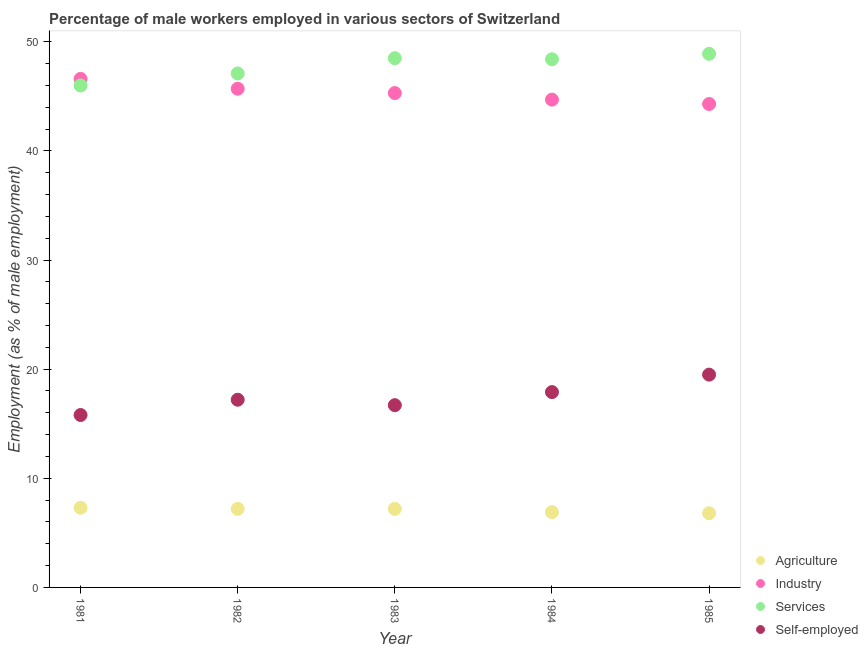How many different coloured dotlines are there?
Offer a terse response. 4. What is the percentage of self employed male workers in 1983?
Keep it short and to the point. 16.7. Across all years, what is the minimum percentage of male workers in agriculture?
Provide a succinct answer. 6.8. In which year was the percentage of self employed male workers maximum?
Offer a very short reply. 1985. What is the total percentage of male workers in industry in the graph?
Your response must be concise. 226.6. What is the difference between the percentage of self employed male workers in 1981 and that in 1983?
Keep it short and to the point. -0.9. What is the difference between the percentage of self employed male workers in 1981 and the percentage of male workers in industry in 1984?
Offer a terse response. -28.9. What is the average percentage of male workers in industry per year?
Make the answer very short. 45.32. In the year 1983, what is the difference between the percentage of self employed male workers and percentage of male workers in services?
Your response must be concise. -31.8. Is the percentage of male workers in agriculture in 1981 less than that in 1984?
Make the answer very short. No. What is the difference between the highest and the second highest percentage of male workers in agriculture?
Provide a succinct answer. 0.1. What is the difference between the highest and the lowest percentage of male workers in industry?
Make the answer very short. 2.3. Is it the case that in every year, the sum of the percentage of male workers in agriculture and percentage of self employed male workers is greater than the sum of percentage of male workers in services and percentage of male workers in industry?
Provide a succinct answer. No. Does the percentage of male workers in industry monotonically increase over the years?
Offer a terse response. No. Is the percentage of male workers in services strictly less than the percentage of male workers in agriculture over the years?
Your response must be concise. No. Are the values on the major ticks of Y-axis written in scientific E-notation?
Make the answer very short. No. Does the graph contain any zero values?
Your response must be concise. No. How many legend labels are there?
Your answer should be very brief. 4. What is the title of the graph?
Keep it short and to the point. Percentage of male workers employed in various sectors of Switzerland. Does "Tertiary schools" appear as one of the legend labels in the graph?
Your answer should be compact. No. What is the label or title of the Y-axis?
Offer a very short reply. Employment (as % of male employment). What is the Employment (as % of male employment) in Agriculture in 1981?
Offer a very short reply. 7.3. What is the Employment (as % of male employment) in Industry in 1981?
Your answer should be very brief. 46.6. What is the Employment (as % of male employment) of Self-employed in 1981?
Give a very brief answer. 15.8. What is the Employment (as % of male employment) of Agriculture in 1982?
Provide a succinct answer. 7.2. What is the Employment (as % of male employment) in Industry in 1982?
Keep it short and to the point. 45.7. What is the Employment (as % of male employment) in Services in 1982?
Make the answer very short. 47.1. What is the Employment (as % of male employment) of Self-employed in 1982?
Provide a succinct answer. 17.2. What is the Employment (as % of male employment) of Agriculture in 1983?
Provide a succinct answer. 7.2. What is the Employment (as % of male employment) of Industry in 1983?
Provide a succinct answer. 45.3. What is the Employment (as % of male employment) in Services in 1983?
Give a very brief answer. 48.5. What is the Employment (as % of male employment) in Self-employed in 1983?
Provide a succinct answer. 16.7. What is the Employment (as % of male employment) of Agriculture in 1984?
Offer a terse response. 6.9. What is the Employment (as % of male employment) of Industry in 1984?
Ensure brevity in your answer.  44.7. What is the Employment (as % of male employment) in Services in 1984?
Keep it short and to the point. 48.4. What is the Employment (as % of male employment) in Self-employed in 1984?
Ensure brevity in your answer.  17.9. What is the Employment (as % of male employment) in Agriculture in 1985?
Your answer should be compact. 6.8. What is the Employment (as % of male employment) of Industry in 1985?
Offer a terse response. 44.3. What is the Employment (as % of male employment) in Services in 1985?
Your answer should be very brief. 48.9. What is the Employment (as % of male employment) in Self-employed in 1985?
Ensure brevity in your answer.  19.5. Across all years, what is the maximum Employment (as % of male employment) of Agriculture?
Provide a short and direct response. 7.3. Across all years, what is the maximum Employment (as % of male employment) in Industry?
Provide a short and direct response. 46.6. Across all years, what is the maximum Employment (as % of male employment) in Services?
Provide a succinct answer. 48.9. Across all years, what is the minimum Employment (as % of male employment) in Agriculture?
Your answer should be compact. 6.8. Across all years, what is the minimum Employment (as % of male employment) of Industry?
Ensure brevity in your answer.  44.3. Across all years, what is the minimum Employment (as % of male employment) in Self-employed?
Provide a succinct answer. 15.8. What is the total Employment (as % of male employment) of Agriculture in the graph?
Your response must be concise. 35.4. What is the total Employment (as % of male employment) of Industry in the graph?
Offer a very short reply. 226.6. What is the total Employment (as % of male employment) in Services in the graph?
Provide a short and direct response. 238.9. What is the total Employment (as % of male employment) in Self-employed in the graph?
Keep it short and to the point. 87.1. What is the difference between the Employment (as % of male employment) in Agriculture in 1981 and that in 1982?
Provide a short and direct response. 0.1. What is the difference between the Employment (as % of male employment) of Services in 1981 and that in 1982?
Offer a terse response. -1.1. What is the difference between the Employment (as % of male employment) in Self-employed in 1981 and that in 1982?
Ensure brevity in your answer.  -1.4. What is the difference between the Employment (as % of male employment) in Agriculture in 1981 and that in 1983?
Your answer should be compact. 0.1. What is the difference between the Employment (as % of male employment) in Agriculture in 1981 and that in 1984?
Your response must be concise. 0.4. What is the difference between the Employment (as % of male employment) of Industry in 1981 and that in 1984?
Give a very brief answer. 1.9. What is the difference between the Employment (as % of male employment) in Agriculture in 1981 and that in 1985?
Make the answer very short. 0.5. What is the difference between the Employment (as % of male employment) in Agriculture in 1982 and that in 1983?
Your answer should be compact. 0. What is the difference between the Employment (as % of male employment) in Services in 1982 and that in 1983?
Your answer should be compact. -1.4. What is the difference between the Employment (as % of male employment) of Agriculture in 1982 and that in 1985?
Your response must be concise. 0.4. What is the difference between the Employment (as % of male employment) of Industry in 1982 and that in 1985?
Give a very brief answer. 1.4. What is the difference between the Employment (as % of male employment) of Self-employed in 1982 and that in 1985?
Offer a terse response. -2.3. What is the difference between the Employment (as % of male employment) of Agriculture in 1983 and that in 1984?
Give a very brief answer. 0.3. What is the difference between the Employment (as % of male employment) of Industry in 1983 and that in 1984?
Your answer should be compact. 0.6. What is the difference between the Employment (as % of male employment) in Self-employed in 1983 and that in 1984?
Your answer should be compact. -1.2. What is the difference between the Employment (as % of male employment) of Agriculture in 1983 and that in 1985?
Your answer should be very brief. 0.4. What is the difference between the Employment (as % of male employment) of Services in 1983 and that in 1985?
Keep it short and to the point. -0.4. What is the difference between the Employment (as % of male employment) in Self-employed in 1983 and that in 1985?
Your response must be concise. -2.8. What is the difference between the Employment (as % of male employment) in Industry in 1984 and that in 1985?
Provide a succinct answer. 0.4. What is the difference between the Employment (as % of male employment) in Agriculture in 1981 and the Employment (as % of male employment) in Industry in 1982?
Give a very brief answer. -38.4. What is the difference between the Employment (as % of male employment) of Agriculture in 1981 and the Employment (as % of male employment) of Services in 1982?
Your answer should be compact. -39.8. What is the difference between the Employment (as % of male employment) of Agriculture in 1981 and the Employment (as % of male employment) of Self-employed in 1982?
Keep it short and to the point. -9.9. What is the difference between the Employment (as % of male employment) in Industry in 1981 and the Employment (as % of male employment) in Services in 1982?
Your response must be concise. -0.5. What is the difference between the Employment (as % of male employment) of Industry in 1981 and the Employment (as % of male employment) of Self-employed in 1982?
Offer a terse response. 29.4. What is the difference between the Employment (as % of male employment) of Services in 1981 and the Employment (as % of male employment) of Self-employed in 1982?
Your answer should be compact. 28.8. What is the difference between the Employment (as % of male employment) in Agriculture in 1981 and the Employment (as % of male employment) in Industry in 1983?
Ensure brevity in your answer.  -38. What is the difference between the Employment (as % of male employment) in Agriculture in 1981 and the Employment (as % of male employment) in Services in 1983?
Provide a succinct answer. -41.2. What is the difference between the Employment (as % of male employment) of Agriculture in 1981 and the Employment (as % of male employment) of Self-employed in 1983?
Offer a very short reply. -9.4. What is the difference between the Employment (as % of male employment) in Industry in 1981 and the Employment (as % of male employment) in Services in 1983?
Your response must be concise. -1.9. What is the difference between the Employment (as % of male employment) of Industry in 1981 and the Employment (as % of male employment) of Self-employed in 1983?
Offer a terse response. 29.9. What is the difference between the Employment (as % of male employment) in Services in 1981 and the Employment (as % of male employment) in Self-employed in 1983?
Provide a short and direct response. 29.3. What is the difference between the Employment (as % of male employment) of Agriculture in 1981 and the Employment (as % of male employment) of Industry in 1984?
Offer a very short reply. -37.4. What is the difference between the Employment (as % of male employment) in Agriculture in 1981 and the Employment (as % of male employment) in Services in 1984?
Your answer should be compact. -41.1. What is the difference between the Employment (as % of male employment) of Agriculture in 1981 and the Employment (as % of male employment) of Self-employed in 1984?
Ensure brevity in your answer.  -10.6. What is the difference between the Employment (as % of male employment) in Industry in 1981 and the Employment (as % of male employment) in Self-employed in 1984?
Provide a short and direct response. 28.7. What is the difference between the Employment (as % of male employment) in Services in 1981 and the Employment (as % of male employment) in Self-employed in 1984?
Your answer should be compact. 28.1. What is the difference between the Employment (as % of male employment) of Agriculture in 1981 and the Employment (as % of male employment) of Industry in 1985?
Ensure brevity in your answer.  -37. What is the difference between the Employment (as % of male employment) of Agriculture in 1981 and the Employment (as % of male employment) of Services in 1985?
Keep it short and to the point. -41.6. What is the difference between the Employment (as % of male employment) of Agriculture in 1981 and the Employment (as % of male employment) of Self-employed in 1985?
Your answer should be very brief. -12.2. What is the difference between the Employment (as % of male employment) in Industry in 1981 and the Employment (as % of male employment) in Services in 1985?
Offer a very short reply. -2.3. What is the difference between the Employment (as % of male employment) in Industry in 1981 and the Employment (as % of male employment) in Self-employed in 1985?
Make the answer very short. 27.1. What is the difference between the Employment (as % of male employment) of Services in 1981 and the Employment (as % of male employment) of Self-employed in 1985?
Offer a terse response. 26.5. What is the difference between the Employment (as % of male employment) of Agriculture in 1982 and the Employment (as % of male employment) of Industry in 1983?
Your answer should be compact. -38.1. What is the difference between the Employment (as % of male employment) of Agriculture in 1982 and the Employment (as % of male employment) of Services in 1983?
Keep it short and to the point. -41.3. What is the difference between the Employment (as % of male employment) of Agriculture in 1982 and the Employment (as % of male employment) of Self-employed in 1983?
Your response must be concise. -9.5. What is the difference between the Employment (as % of male employment) of Services in 1982 and the Employment (as % of male employment) of Self-employed in 1983?
Make the answer very short. 30.4. What is the difference between the Employment (as % of male employment) in Agriculture in 1982 and the Employment (as % of male employment) in Industry in 1984?
Your response must be concise. -37.5. What is the difference between the Employment (as % of male employment) of Agriculture in 1982 and the Employment (as % of male employment) of Services in 1984?
Your answer should be very brief. -41.2. What is the difference between the Employment (as % of male employment) in Industry in 1982 and the Employment (as % of male employment) in Self-employed in 1984?
Your answer should be compact. 27.8. What is the difference between the Employment (as % of male employment) in Services in 1982 and the Employment (as % of male employment) in Self-employed in 1984?
Provide a short and direct response. 29.2. What is the difference between the Employment (as % of male employment) of Agriculture in 1982 and the Employment (as % of male employment) of Industry in 1985?
Provide a succinct answer. -37.1. What is the difference between the Employment (as % of male employment) in Agriculture in 1982 and the Employment (as % of male employment) in Services in 1985?
Provide a succinct answer. -41.7. What is the difference between the Employment (as % of male employment) of Industry in 1982 and the Employment (as % of male employment) of Services in 1985?
Offer a terse response. -3.2. What is the difference between the Employment (as % of male employment) of Industry in 1982 and the Employment (as % of male employment) of Self-employed in 1985?
Give a very brief answer. 26.2. What is the difference between the Employment (as % of male employment) of Services in 1982 and the Employment (as % of male employment) of Self-employed in 1985?
Keep it short and to the point. 27.6. What is the difference between the Employment (as % of male employment) in Agriculture in 1983 and the Employment (as % of male employment) in Industry in 1984?
Offer a terse response. -37.5. What is the difference between the Employment (as % of male employment) in Agriculture in 1983 and the Employment (as % of male employment) in Services in 1984?
Your response must be concise. -41.2. What is the difference between the Employment (as % of male employment) in Industry in 1983 and the Employment (as % of male employment) in Services in 1984?
Offer a terse response. -3.1. What is the difference between the Employment (as % of male employment) in Industry in 1983 and the Employment (as % of male employment) in Self-employed in 1984?
Your answer should be compact. 27.4. What is the difference between the Employment (as % of male employment) in Services in 1983 and the Employment (as % of male employment) in Self-employed in 1984?
Give a very brief answer. 30.6. What is the difference between the Employment (as % of male employment) in Agriculture in 1983 and the Employment (as % of male employment) in Industry in 1985?
Keep it short and to the point. -37.1. What is the difference between the Employment (as % of male employment) of Agriculture in 1983 and the Employment (as % of male employment) of Services in 1985?
Make the answer very short. -41.7. What is the difference between the Employment (as % of male employment) of Agriculture in 1983 and the Employment (as % of male employment) of Self-employed in 1985?
Offer a terse response. -12.3. What is the difference between the Employment (as % of male employment) of Industry in 1983 and the Employment (as % of male employment) of Self-employed in 1985?
Ensure brevity in your answer.  25.8. What is the difference between the Employment (as % of male employment) of Agriculture in 1984 and the Employment (as % of male employment) of Industry in 1985?
Keep it short and to the point. -37.4. What is the difference between the Employment (as % of male employment) of Agriculture in 1984 and the Employment (as % of male employment) of Services in 1985?
Keep it short and to the point. -42. What is the difference between the Employment (as % of male employment) in Agriculture in 1984 and the Employment (as % of male employment) in Self-employed in 1985?
Make the answer very short. -12.6. What is the difference between the Employment (as % of male employment) in Industry in 1984 and the Employment (as % of male employment) in Self-employed in 1985?
Your answer should be compact. 25.2. What is the difference between the Employment (as % of male employment) in Services in 1984 and the Employment (as % of male employment) in Self-employed in 1985?
Ensure brevity in your answer.  28.9. What is the average Employment (as % of male employment) of Agriculture per year?
Ensure brevity in your answer.  7.08. What is the average Employment (as % of male employment) of Industry per year?
Your response must be concise. 45.32. What is the average Employment (as % of male employment) of Services per year?
Ensure brevity in your answer.  47.78. What is the average Employment (as % of male employment) in Self-employed per year?
Provide a succinct answer. 17.42. In the year 1981, what is the difference between the Employment (as % of male employment) in Agriculture and Employment (as % of male employment) in Industry?
Your answer should be very brief. -39.3. In the year 1981, what is the difference between the Employment (as % of male employment) of Agriculture and Employment (as % of male employment) of Services?
Your response must be concise. -38.7. In the year 1981, what is the difference between the Employment (as % of male employment) in Agriculture and Employment (as % of male employment) in Self-employed?
Offer a very short reply. -8.5. In the year 1981, what is the difference between the Employment (as % of male employment) in Industry and Employment (as % of male employment) in Self-employed?
Keep it short and to the point. 30.8. In the year 1981, what is the difference between the Employment (as % of male employment) of Services and Employment (as % of male employment) of Self-employed?
Give a very brief answer. 30.2. In the year 1982, what is the difference between the Employment (as % of male employment) of Agriculture and Employment (as % of male employment) of Industry?
Offer a very short reply. -38.5. In the year 1982, what is the difference between the Employment (as % of male employment) of Agriculture and Employment (as % of male employment) of Services?
Your answer should be very brief. -39.9. In the year 1982, what is the difference between the Employment (as % of male employment) of Industry and Employment (as % of male employment) of Services?
Keep it short and to the point. -1.4. In the year 1982, what is the difference between the Employment (as % of male employment) in Industry and Employment (as % of male employment) in Self-employed?
Provide a short and direct response. 28.5. In the year 1982, what is the difference between the Employment (as % of male employment) of Services and Employment (as % of male employment) of Self-employed?
Provide a succinct answer. 29.9. In the year 1983, what is the difference between the Employment (as % of male employment) of Agriculture and Employment (as % of male employment) of Industry?
Provide a short and direct response. -38.1. In the year 1983, what is the difference between the Employment (as % of male employment) in Agriculture and Employment (as % of male employment) in Services?
Keep it short and to the point. -41.3. In the year 1983, what is the difference between the Employment (as % of male employment) in Agriculture and Employment (as % of male employment) in Self-employed?
Your answer should be very brief. -9.5. In the year 1983, what is the difference between the Employment (as % of male employment) in Industry and Employment (as % of male employment) in Self-employed?
Give a very brief answer. 28.6. In the year 1983, what is the difference between the Employment (as % of male employment) of Services and Employment (as % of male employment) of Self-employed?
Provide a succinct answer. 31.8. In the year 1984, what is the difference between the Employment (as % of male employment) of Agriculture and Employment (as % of male employment) of Industry?
Give a very brief answer. -37.8. In the year 1984, what is the difference between the Employment (as % of male employment) of Agriculture and Employment (as % of male employment) of Services?
Offer a very short reply. -41.5. In the year 1984, what is the difference between the Employment (as % of male employment) of Industry and Employment (as % of male employment) of Services?
Offer a very short reply. -3.7. In the year 1984, what is the difference between the Employment (as % of male employment) in Industry and Employment (as % of male employment) in Self-employed?
Provide a succinct answer. 26.8. In the year 1984, what is the difference between the Employment (as % of male employment) of Services and Employment (as % of male employment) of Self-employed?
Your response must be concise. 30.5. In the year 1985, what is the difference between the Employment (as % of male employment) in Agriculture and Employment (as % of male employment) in Industry?
Your answer should be compact. -37.5. In the year 1985, what is the difference between the Employment (as % of male employment) in Agriculture and Employment (as % of male employment) in Services?
Keep it short and to the point. -42.1. In the year 1985, what is the difference between the Employment (as % of male employment) of Agriculture and Employment (as % of male employment) of Self-employed?
Your answer should be very brief. -12.7. In the year 1985, what is the difference between the Employment (as % of male employment) of Industry and Employment (as % of male employment) of Self-employed?
Keep it short and to the point. 24.8. In the year 1985, what is the difference between the Employment (as % of male employment) in Services and Employment (as % of male employment) in Self-employed?
Keep it short and to the point. 29.4. What is the ratio of the Employment (as % of male employment) in Agriculture in 1981 to that in 1982?
Make the answer very short. 1.01. What is the ratio of the Employment (as % of male employment) in Industry in 1981 to that in 1982?
Provide a short and direct response. 1.02. What is the ratio of the Employment (as % of male employment) in Services in 1981 to that in 1982?
Your response must be concise. 0.98. What is the ratio of the Employment (as % of male employment) in Self-employed in 1981 to that in 1982?
Make the answer very short. 0.92. What is the ratio of the Employment (as % of male employment) of Agriculture in 1981 to that in 1983?
Your response must be concise. 1.01. What is the ratio of the Employment (as % of male employment) in Industry in 1981 to that in 1983?
Make the answer very short. 1.03. What is the ratio of the Employment (as % of male employment) of Services in 1981 to that in 1983?
Provide a succinct answer. 0.95. What is the ratio of the Employment (as % of male employment) of Self-employed in 1981 to that in 1983?
Provide a succinct answer. 0.95. What is the ratio of the Employment (as % of male employment) in Agriculture in 1981 to that in 1984?
Your response must be concise. 1.06. What is the ratio of the Employment (as % of male employment) in Industry in 1981 to that in 1984?
Give a very brief answer. 1.04. What is the ratio of the Employment (as % of male employment) of Services in 1981 to that in 1984?
Keep it short and to the point. 0.95. What is the ratio of the Employment (as % of male employment) of Self-employed in 1981 to that in 1984?
Your answer should be very brief. 0.88. What is the ratio of the Employment (as % of male employment) of Agriculture in 1981 to that in 1985?
Offer a terse response. 1.07. What is the ratio of the Employment (as % of male employment) in Industry in 1981 to that in 1985?
Offer a terse response. 1.05. What is the ratio of the Employment (as % of male employment) of Services in 1981 to that in 1985?
Provide a short and direct response. 0.94. What is the ratio of the Employment (as % of male employment) in Self-employed in 1981 to that in 1985?
Your answer should be very brief. 0.81. What is the ratio of the Employment (as % of male employment) in Agriculture in 1982 to that in 1983?
Offer a terse response. 1. What is the ratio of the Employment (as % of male employment) of Industry in 1982 to that in 1983?
Give a very brief answer. 1.01. What is the ratio of the Employment (as % of male employment) of Services in 1982 to that in 1983?
Offer a terse response. 0.97. What is the ratio of the Employment (as % of male employment) in Self-employed in 1982 to that in 1983?
Provide a succinct answer. 1.03. What is the ratio of the Employment (as % of male employment) in Agriculture in 1982 to that in 1984?
Offer a terse response. 1.04. What is the ratio of the Employment (as % of male employment) in Industry in 1982 to that in 1984?
Offer a terse response. 1.02. What is the ratio of the Employment (as % of male employment) of Services in 1982 to that in 1984?
Provide a succinct answer. 0.97. What is the ratio of the Employment (as % of male employment) in Self-employed in 1982 to that in 1984?
Offer a very short reply. 0.96. What is the ratio of the Employment (as % of male employment) in Agriculture in 1982 to that in 1985?
Offer a very short reply. 1.06. What is the ratio of the Employment (as % of male employment) in Industry in 1982 to that in 1985?
Ensure brevity in your answer.  1.03. What is the ratio of the Employment (as % of male employment) of Services in 1982 to that in 1985?
Your answer should be compact. 0.96. What is the ratio of the Employment (as % of male employment) of Self-employed in 1982 to that in 1985?
Make the answer very short. 0.88. What is the ratio of the Employment (as % of male employment) of Agriculture in 1983 to that in 1984?
Provide a succinct answer. 1.04. What is the ratio of the Employment (as % of male employment) of Industry in 1983 to that in 1984?
Make the answer very short. 1.01. What is the ratio of the Employment (as % of male employment) in Services in 1983 to that in 1984?
Give a very brief answer. 1. What is the ratio of the Employment (as % of male employment) of Self-employed in 1983 to that in 1984?
Your response must be concise. 0.93. What is the ratio of the Employment (as % of male employment) in Agriculture in 1983 to that in 1985?
Your answer should be compact. 1.06. What is the ratio of the Employment (as % of male employment) in Industry in 1983 to that in 1985?
Your answer should be very brief. 1.02. What is the ratio of the Employment (as % of male employment) in Self-employed in 1983 to that in 1985?
Your answer should be very brief. 0.86. What is the ratio of the Employment (as % of male employment) of Agriculture in 1984 to that in 1985?
Make the answer very short. 1.01. What is the ratio of the Employment (as % of male employment) of Industry in 1984 to that in 1985?
Ensure brevity in your answer.  1.01. What is the ratio of the Employment (as % of male employment) of Self-employed in 1984 to that in 1985?
Your answer should be very brief. 0.92. What is the difference between the highest and the second highest Employment (as % of male employment) of Industry?
Provide a succinct answer. 0.9. What is the difference between the highest and the second highest Employment (as % of male employment) of Services?
Your response must be concise. 0.4. What is the difference between the highest and the lowest Employment (as % of male employment) of Agriculture?
Your answer should be very brief. 0.5. What is the difference between the highest and the lowest Employment (as % of male employment) in Services?
Offer a very short reply. 2.9. 